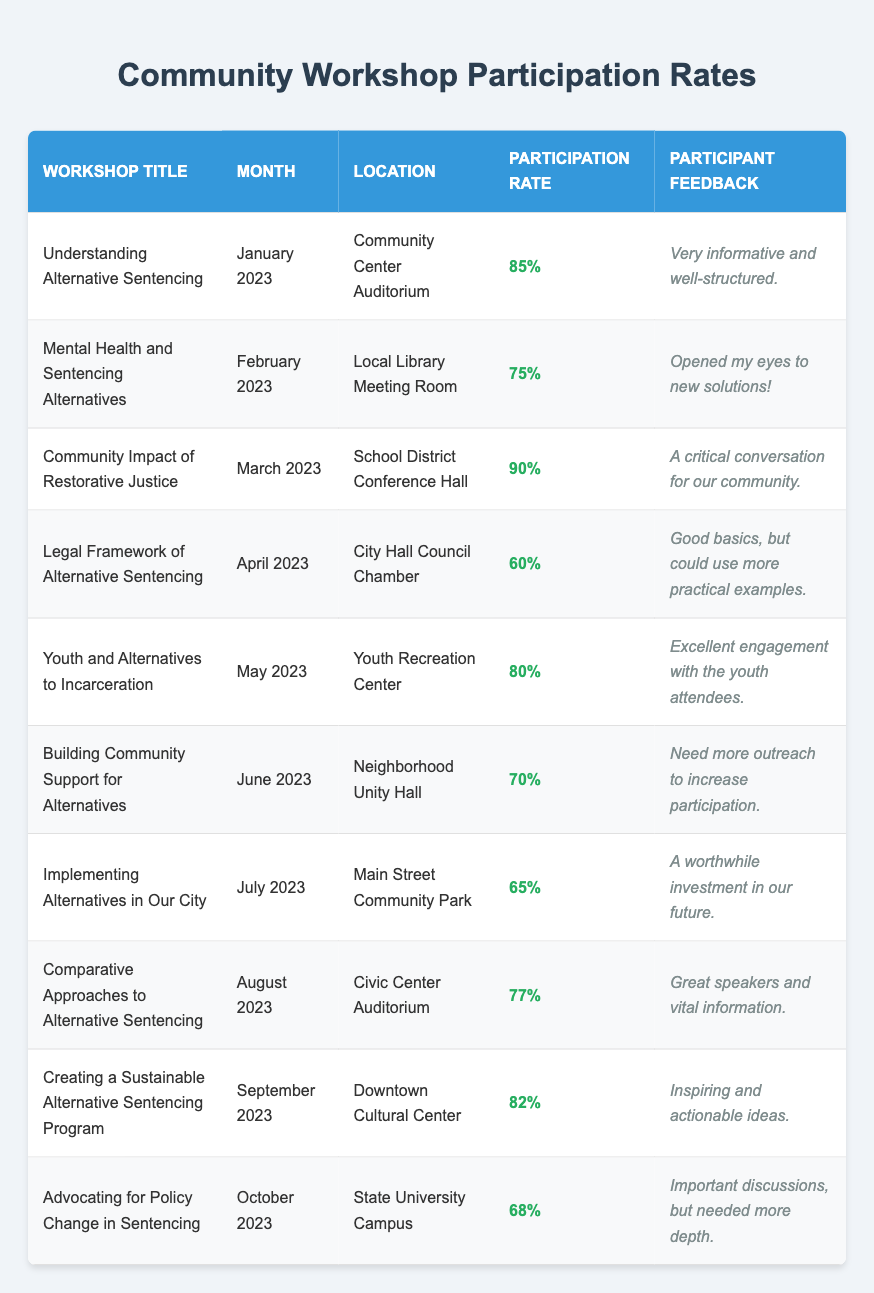What was the highest participation rate for a workshop? The highest participation rate in the table is found by comparing all the rates listed. Among the percentages, 90% from "Community Impact of Restorative Justice" in March 2023 is the highest.
Answer: 90% Which workshop had the lowest participation rate? Looking through the participation rates, "Legal Framework of Alternative Sentencing" in April 2023 has the lowest rate of 60%.
Answer: 60% What was the participation rate for "Youth and Alternatives to Incarceration"? The participation rate for "Youth and Alternatives to Incarceration," listed under May 2023, is 80%.
Answer: 80% What feedback was given regarding the "Implementing Alternatives in Our City" workshop? The feedback for "Implementing Alternatives in Our City," held in July 2023, was "A worthwhile investment in our future."
Answer: A worthwhile investment in our future How many workshops had a participation rate of 70% or more? Counting the workshops with rates of 70% or above from the table: "Understanding Alternative Sentencing" (85%), "Community Impact of Restorative Justice" (90%), "Youth and Alternatives to Incarceration" (80%), "Creating a Sustainable Alternative Sentencing Program" (82%), and "Mental Health and Sentencing Alternatives" (75%) gives us a total of 5 workshops.
Answer: 5 What is the average participation rate across all workshops? To calculate the average, first sum all participation rates: 85 + 75 + 90 + 60 + 80 + 70 + 65 + 77 + 82 + 68 =  67.7. Then, divide by 10 (the number of workshops):  67.7 / 10 = 72.7.
Answer: 72.7 Was the participation rate for "Advocating for Policy Change in Sentencing" above or below the average participation rate? As calculated, the average participation rate is 72.7%. The participation rate for "Advocating for Policy Change in Sentencing" is 68%, which is below the average participation rate.
Answer: Below Which month had the workshop with the highest feedback rating? The workshop in March 2023, "Community Impact of Restorative Justice," had the highest participation rate and feedback stating it was "A critical conversation for our community," indicating a strong positive sentiment. While both high participation and positive feedback suggest this month stands out.
Answer: March 2023 Which workshops indicate a need for more outreach? The workshop titled "Building Community Support for Alternatives" in June 2023 explicitly states the need for "more outreach to increase participation," indicating a recognition of lower engagement.
Answer: June 2023 How many workshops were held from January to March 2023? The table lists three workshops from January 2023 ("Understanding Alternative Sentencing"), February 2023 ("Mental Health and Sentencing Alternatives"), and March 2023 ("Community Impact of Restorative Justice"). Therefore, there were 3 workshops.
Answer: 3 